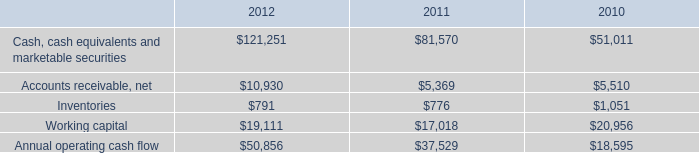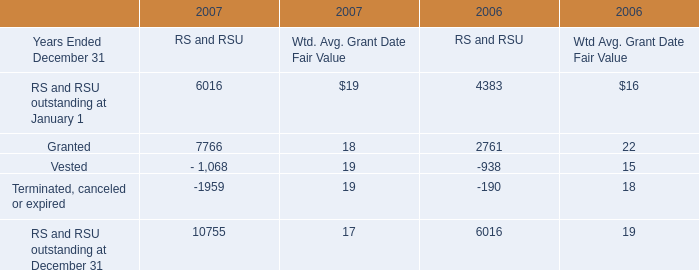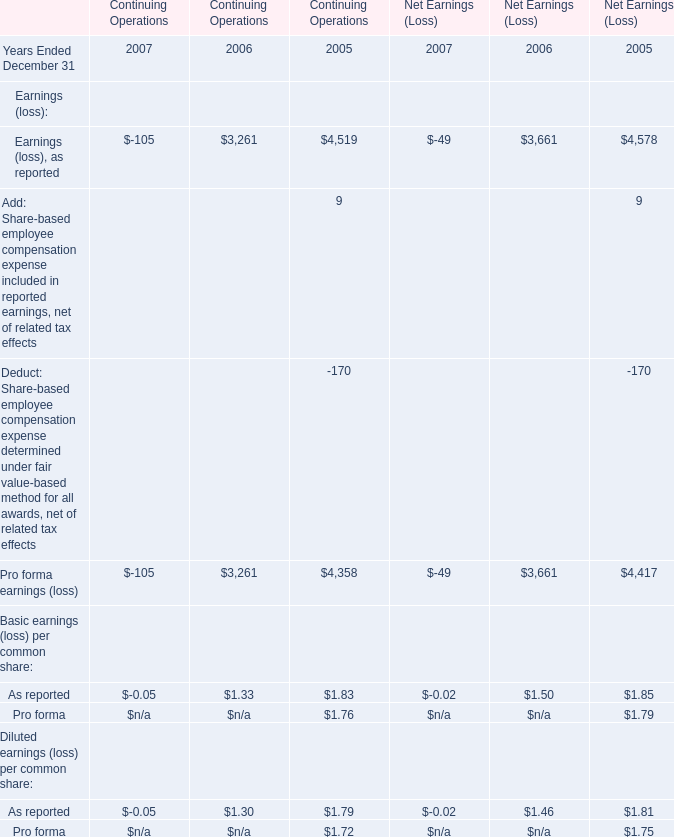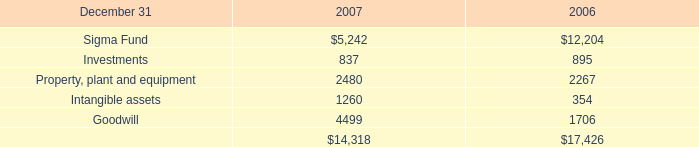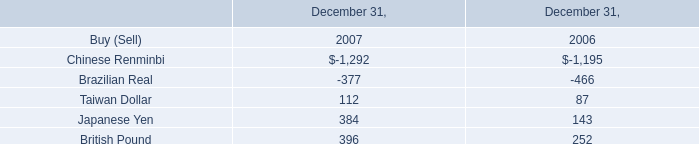Which year is Vested the most for RS and RSU? 
Answer: 2006. 